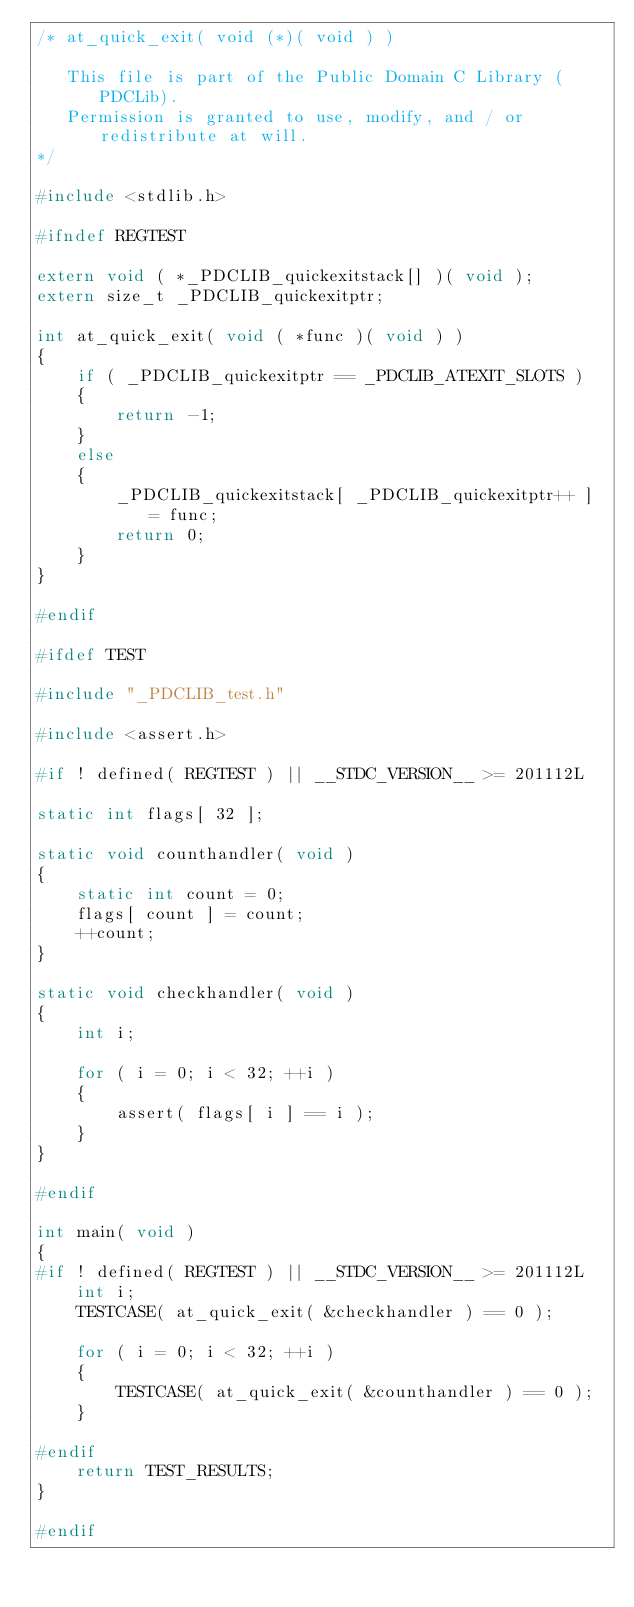Convert code to text. <code><loc_0><loc_0><loc_500><loc_500><_C_>/* at_quick_exit( void (*)( void ) )

   This file is part of the Public Domain C Library (PDCLib).
   Permission is granted to use, modify, and / or redistribute at will.
*/

#include <stdlib.h>

#ifndef REGTEST

extern void ( *_PDCLIB_quickexitstack[] )( void );
extern size_t _PDCLIB_quickexitptr;

int at_quick_exit( void ( *func )( void ) )
{
    if ( _PDCLIB_quickexitptr == _PDCLIB_ATEXIT_SLOTS )
    {
        return -1;
    }
    else
    {
        _PDCLIB_quickexitstack[ _PDCLIB_quickexitptr++ ] = func;
        return 0;
    }
}

#endif

#ifdef TEST

#include "_PDCLIB_test.h"

#include <assert.h>

#if ! defined( REGTEST ) || __STDC_VERSION__ >= 201112L

static int flags[ 32 ];

static void counthandler( void )
{
    static int count = 0;
    flags[ count ] = count;
    ++count;
}

static void checkhandler( void )
{
    int i;

    for ( i = 0; i < 32; ++i )
    {
        assert( flags[ i ] == i );
    }
}

#endif

int main( void )
{
#if ! defined( REGTEST ) || __STDC_VERSION__ >= 201112L
    int i;
    TESTCASE( at_quick_exit( &checkhandler ) == 0 );

    for ( i = 0; i < 32; ++i )
    {
        TESTCASE( at_quick_exit( &counthandler ) == 0 );
    }

#endif
    return TEST_RESULTS;
}

#endif
</code> 